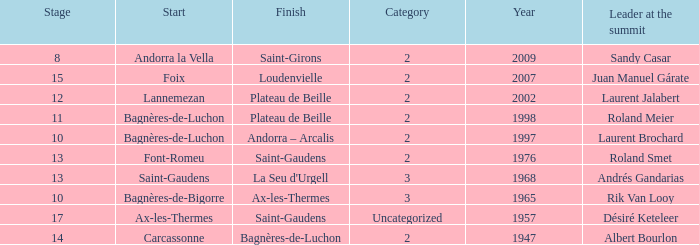Give the Finish for a Stage that is larger than 15 Saint-Gaudens. 